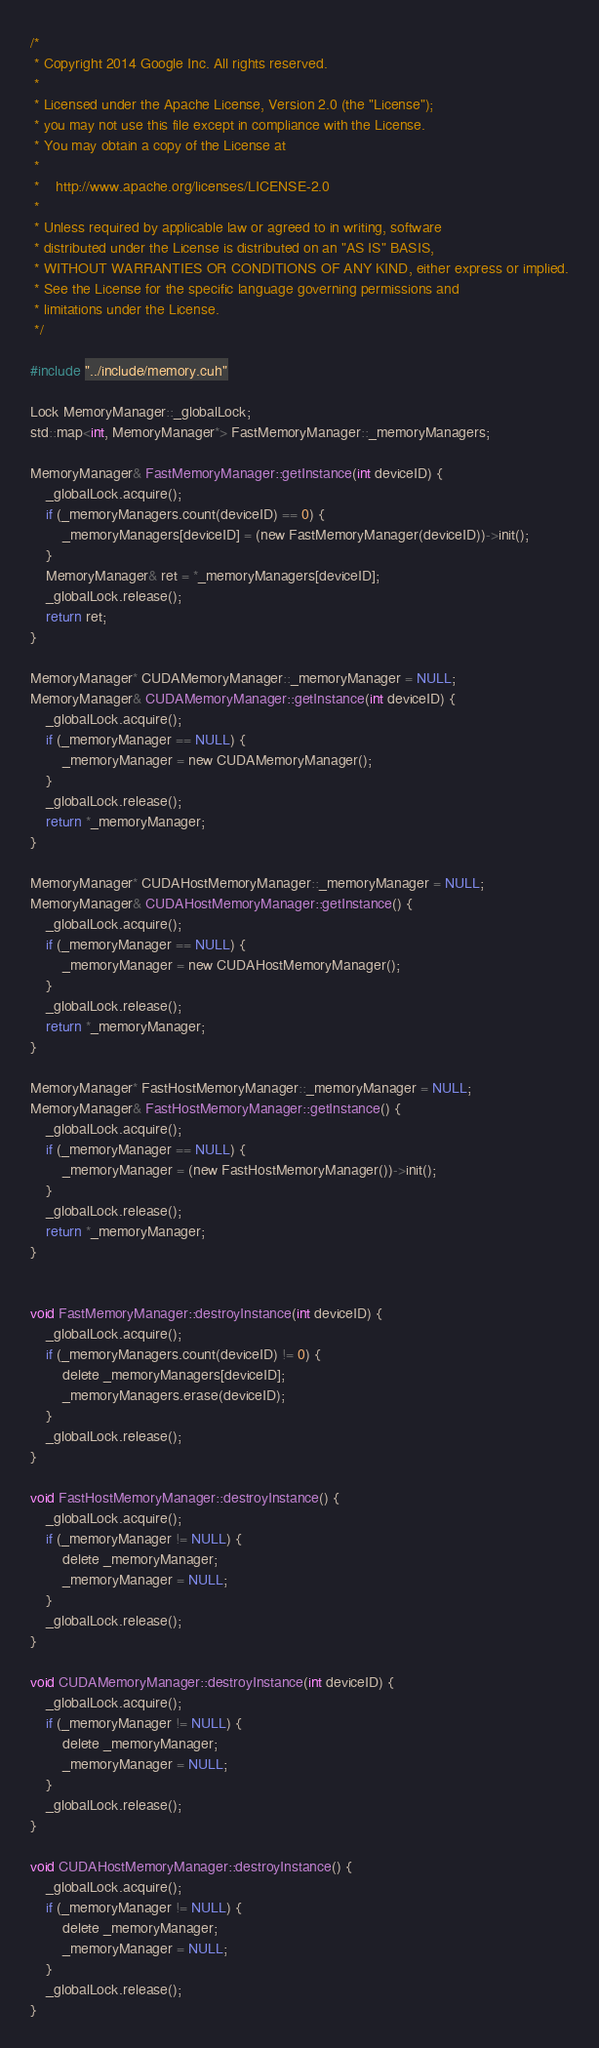<code> <loc_0><loc_0><loc_500><loc_500><_Cuda_>/*
 * Copyright 2014 Google Inc. All rights reserved.
 *
 * Licensed under the Apache License, Version 2.0 (the "License");
 * you may not use this file except in compliance with the License.
 * You may obtain a copy of the License at
 *
 *    http://www.apache.org/licenses/LICENSE-2.0
 *
 * Unless required by applicable law or agreed to in writing, software
 * distributed under the License is distributed on an "AS IS" BASIS,
 * WITHOUT WARRANTIES OR CONDITIONS OF ANY KIND, either express or implied.
 * See the License for the specific language governing permissions and
 * limitations under the License.
 */

#include "../include/memory.cuh"

Lock MemoryManager::_globalLock;
std::map<int, MemoryManager*> FastMemoryManager::_memoryManagers;

MemoryManager& FastMemoryManager::getInstance(int deviceID) {
    _globalLock.acquire();
    if (_memoryManagers.count(deviceID) == 0) {
        _memoryManagers[deviceID] = (new FastMemoryManager(deviceID))->init();
    }
    MemoryManager& ret = *_memoryManagers[deviceID];
    _globalLock.release();
    return ret;
}

MemoryManager* CUDAMemoryManager::_memoryManager = NULL;
MemoryManager& CUDAMemoryManager::getInstance(int deviceID) {
    _globalLock.acquire();
    if (_memoryManager == NULL) {
        _memoryManager = new CUDAMemoryManager();
    }
    _globalLock.release();
    return *_memoryManager;
}

MemoryManager* CUDAHostMemoryManager::_memoryManager = NULL;
MemoryManager& CUDAHostMemoryManager::getInstance() {
    _globalLock.acquire();
    if (_memoryManager == NULL) {
        _memoryManager = new CUDAHostMemoryManager();
    }
    _globalLock.release();
    return *_memoryManager;
}

MemoryManager* FastHostMemoryManager::_memoryManager = NULL;
MemoryManager& FastHostMemoryManager::getInstance() {
    _globalLock.acquire();
    if (_memoryManager == NULL) {
        _memoryManager = (new FastHostMemoryManager())->init();
    }
    _globalLock.release();
    return *_memoryManager;
}


void FastMemoryManager::destroyInstance(int deviceID) {
    _globalLock.acquire();
    if (_memoryManagers.count(deviceID) != 0) {
        delete _memoryManagers[deviceID];
        _memoryManagers.erase(deviceID);
    }
    _globalLock.release();
}

void FastHostMemoryManager::destroyInstance() {
    _globalLock.acquire();
    if (_memoryManager != NULL) {
        delete _memoryManager;
        _memoryManager = NULL;
    }
    _globalLock.release();
}

void CUDAMemoryManager::destroyInstance(int deviceID) {
    _globalLock.acquire();
    if (_memoryManager != NULL) {
        delete _memoryManager;
        _memoryManager = NULL;
    }
    _globalLock.release();
}

void CUDAHostMemoryManager::destroyInstance() {
    _globalLock.acquire();
    if (_memoryManager != NULL) {
        delete _memoryManager;
        _memoryManager = NULL;
    }
    _globalLock.release();
}
</code> 